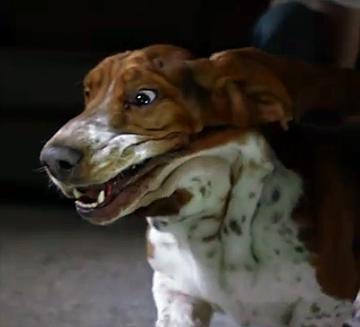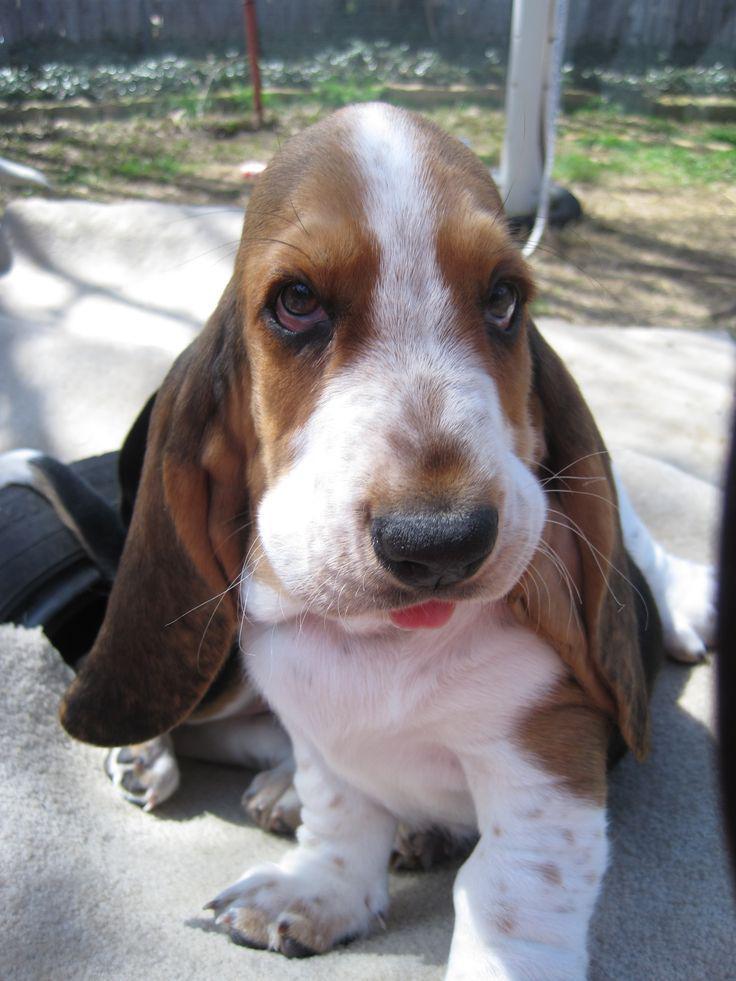The first image is the image on the left, the second image is the image on the right. Evaluate the accuracy of this statement regarding the images: "The right image includes a tri-color dog in an upright profile pose with its front paws raised off the ground.". Is it true? Answer yes or no. No. The first image is the image on the left, the second image is the image on the right. For the images displayed, is the sentence "One of the images shows a dog with its two front paws off the ground." factually correct? Answer yes or no. No. 